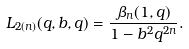Convert formula to latex. <formula><loc_0><loc_0><loc_500><loc_500>L _ { 2 ( n ) } ( q , b , q ) = \frac { \beta _ { n } ( 1 , q ) } { 1 - b ^ { 2 } q ^ { 2 n } } .</formula> 